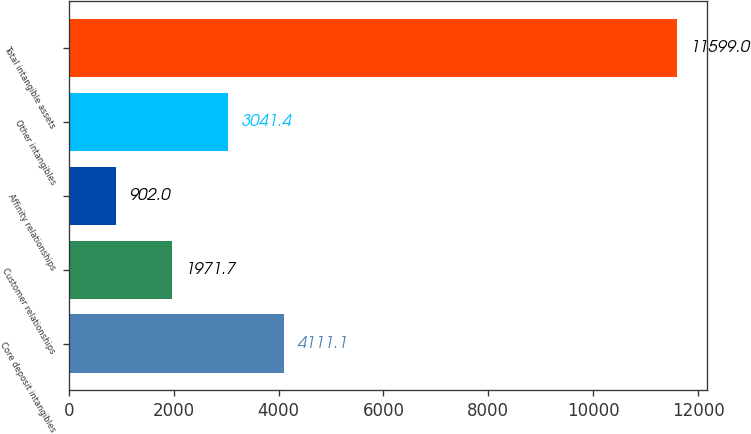Convert chart to OTSL. <chart><loc_0><loc_0><loc_500><loc_500><bar_chart><fcel>Core deposit intangibles<fcel>Customer relationships<fcel>Affinity relationships<fcel>Other intangibles<fcel>Total intangible assets<nl><fcel>4111.1<fcel>1971.7<fcel>902<fcel>3041.4<fcel>11599<nl></chart> 